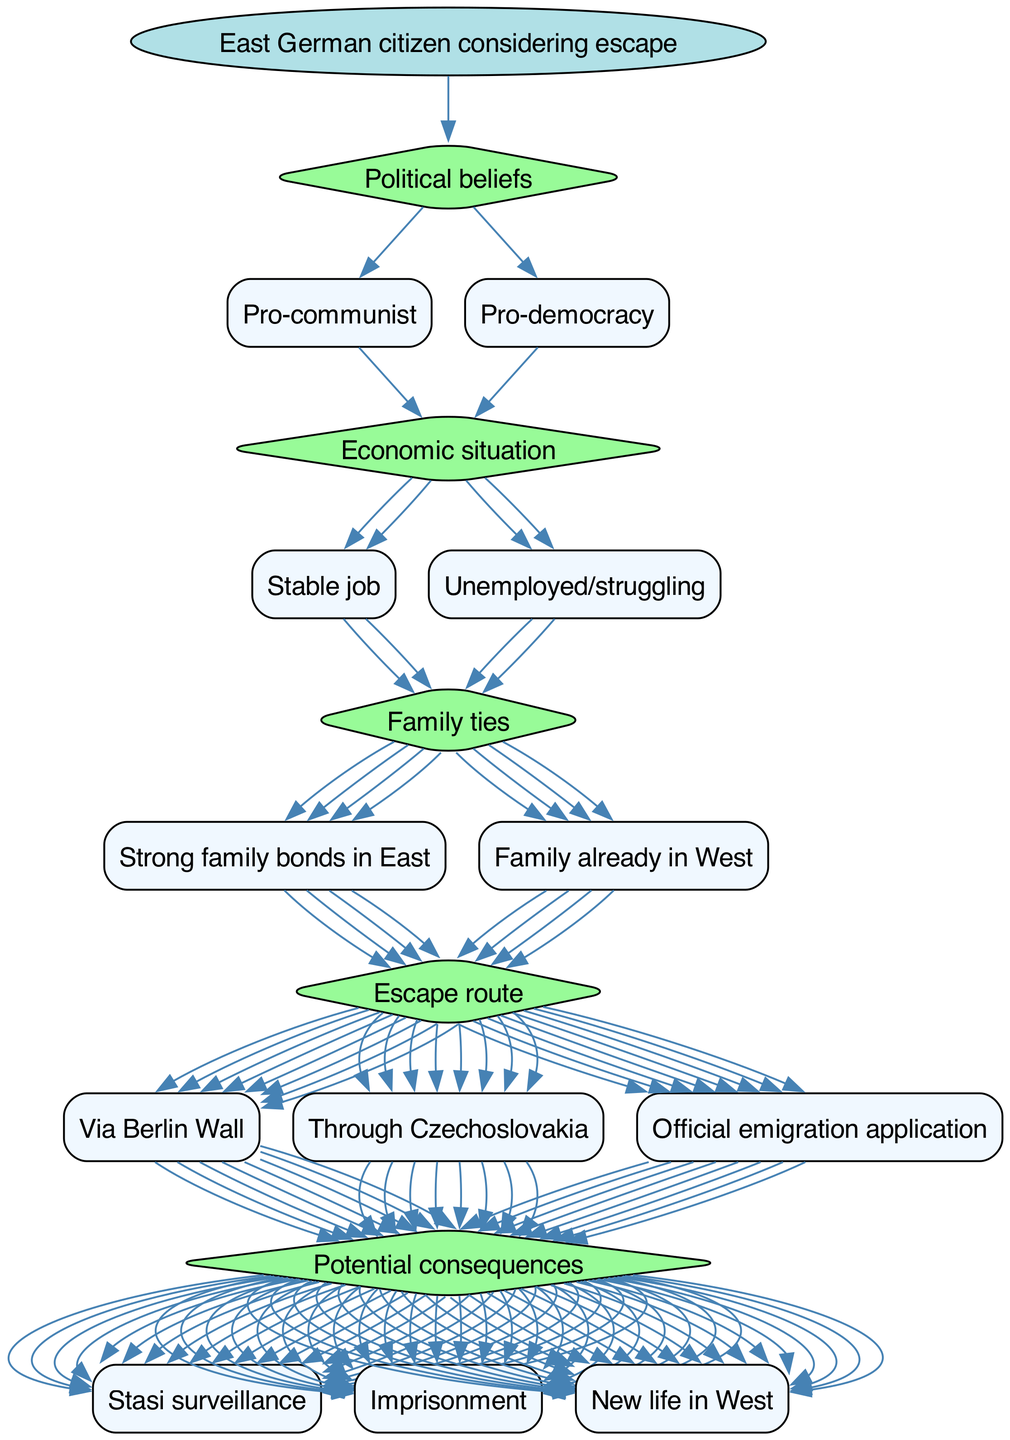What is the root of the decision tree? The diagram indicates that the root of the decision tree is "East German citizen considering escape." This is the starting point from which all decisions branch out.
Answer: East German citizen considering escape How many main decision nodes are in the diagram? By examining the structure of the diagram, there are five main decision nodes: "Political beliefs," "Economic situation," "Family ties," "Escape route," and "Potential consequences." Thus, there are a total of five decision nodes.
Answer: 5 What option is listed under "Family ties"? The options stemming from the "Family ties" node are "Strong family bonds in East" and "Family already in West." One of these options is "Strong family bonds in East."
Answer: Strong family bonds in East How does a citizen's "Economic situation" influence their escape consideration? The "Economic situation" node has two options: "Stable job" and "Unemployed/struggling." A citizen's economic stability likely affects their desire and feasibility to escape, as financial security might reduce the urgency to leave East Germany.
Answer: Stable job / Unemployed/struggling What could potentially result from escaping, according to the diagram? The "Potential consequences" node lists three outcomes: "Stasi surveillance," "Imprisonment," and "New life in West." These represent the various risks and benefits that an East German citizen might weigh when considering escape.
Answer: Stasi surveillance / Imprisonment / New life in West Which escape route has three options listed? The "Escape route" decision node includes three options: "Via Berlin Wall," "Through Czechoslovakia," and "Official emigration application." This node emphasizes different strategies for attempting to escape East Germany.
Answer: Via Berlin Wall / Through Czechoslovakia / Official emigration application If a citizen is pro-democracy and unemployed, what decision nodes relate to them? The citizen's political beliefs would lead them to the "Pro-democracy" option under the "Political beliefs" node, and their economic situation would lead them to the "Unemployed/struggling" option. Thus, both nodes "Political beliefs" and "Economic situation" are relevant.
Answer: Pro-democracy, Unemployed/struggling What is a possible consequence of choosing any escape route? The potential consequence of escaping, regardless of the route, could lead to "Stasi surveillance," "Imprisonment," or experiencing a "New life in West." This represents a risk associated with any attempt to escape.
Answer: Stasi surveillance / Imprisonment / New life in West 